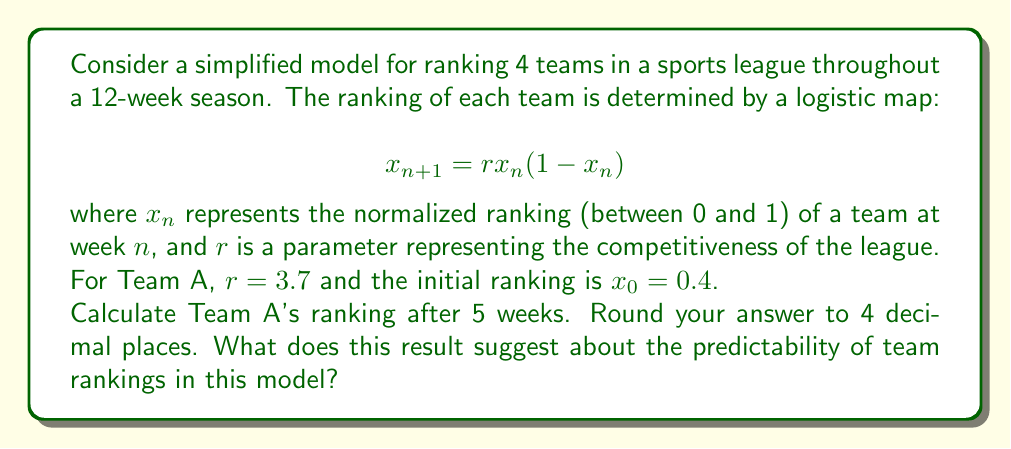Help me with this question. Let's approach this step-by-step:

1) We're using the logistic map: $x_{n+1} = rx_n(1-x_n)$
   Where $r = 3.7$ and $x_0 = 0.4$

2) Let's calculate the rankings for each week:

   Week 1: $x_1 = 3.7 * 0.4 * (1-0.4) = 0.888$
   
   Week 2: $x_2 = 3.7 * 0.888 * (1-0.888) = 0.3687$
   
   Week 3: $x_3 = 3.7 * 0.3687 * (1-0.3687) = 0.8614$
   
   Week 4: $x_4 = 3.7 * 0.8614 * (1-0.8614) = 0.4409$
   
   Week 5: $x_5 = 3.7 * 0.4409 * (1-0.4409) = 0.9124$

3) Rounding to 4 decimal places, we get 0.9124.

4) This result suggests highly unpredictable and chaotic behavior in team rankings. Despite starting at a moderate ranking of 0.4, Team A's ranking fluctuates wildly between high and low values over just 5 weeks.

5) The value of $r = 3.7$ is in the chaotic regime for the logistic map, which explains this behavior. In the context of sports rankings, this could represent a highly competitive league where small differences in performance can lead to large swings in rankings from week to week.

6) This model demonstrates how dynamical systems theory can be applied to understand the complex and often unpredictable nature of sports rankings, reflecting the excitement and uncertainty often seen in collegiate sports competitions.
Answer: 0.9124; suggests chaotic, unpredictable ranking behavior 